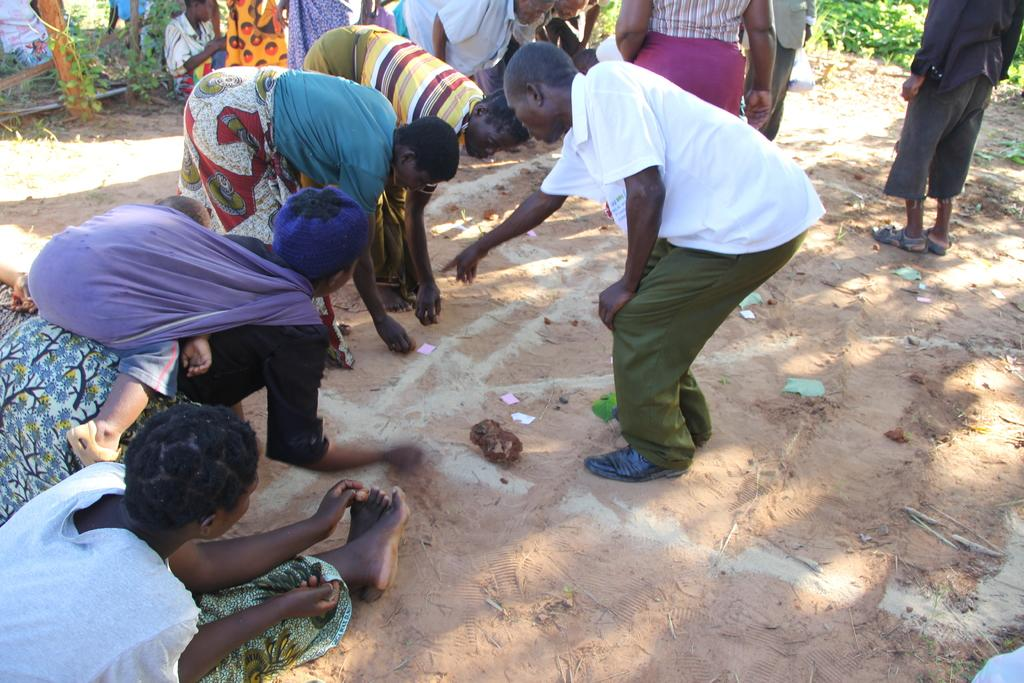What is happening in the middle of the image? There are people sitting and standing in the middle of the image. What type of environment is visible behind the people? There is grass visible behind the people. What type of sun can be seen in the image? There is no sun visible in the image; it only shows people sitting and standing in the grass. 